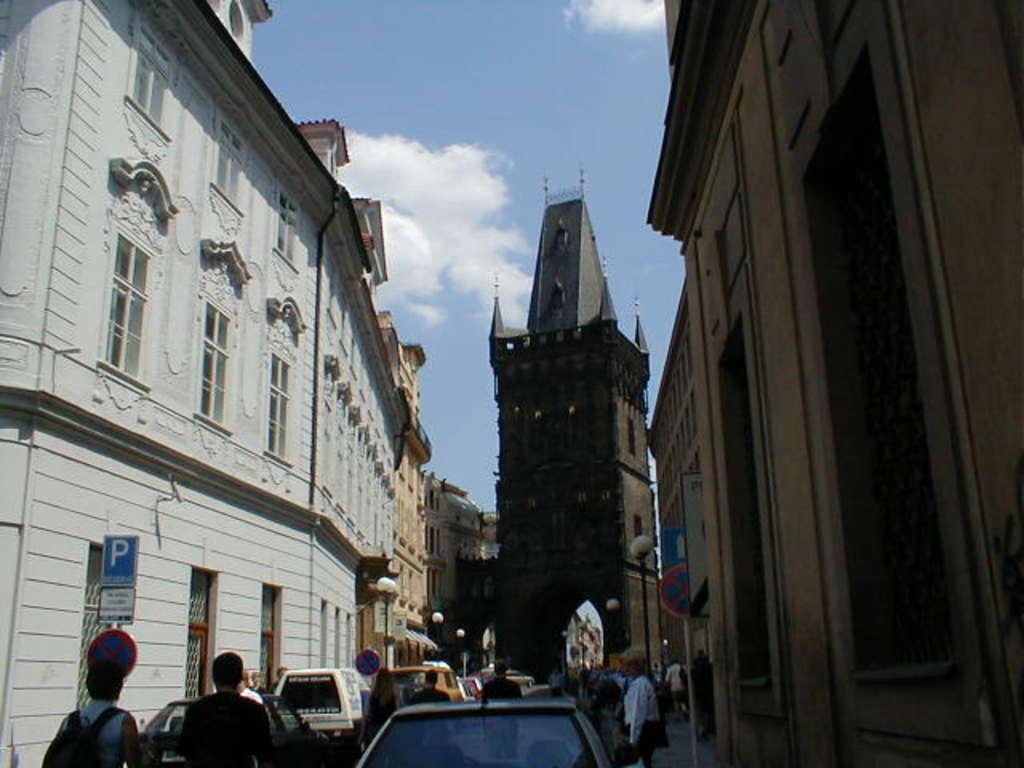Could you give a brief overview of what you see in this image? In the foreground we can see people and cars. On the left there are buildings. On the right there are buildings. In the center of the background there are buildings. At the top there is sky. 